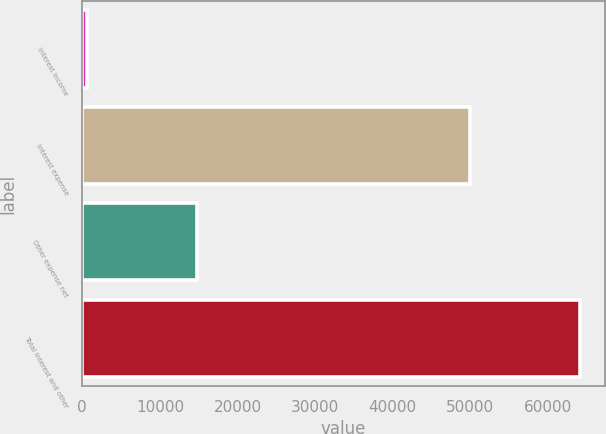<chart> <loc_0><loc_0><loc_500><loc_500><bar_chart><fcel>Interest income<fcel>Interest expense<fcel>Other expense net<fcel>Total interest and other<nl><fcel>650<fcel>49924<fcel>14836<fcel>64110<nl></chart> 